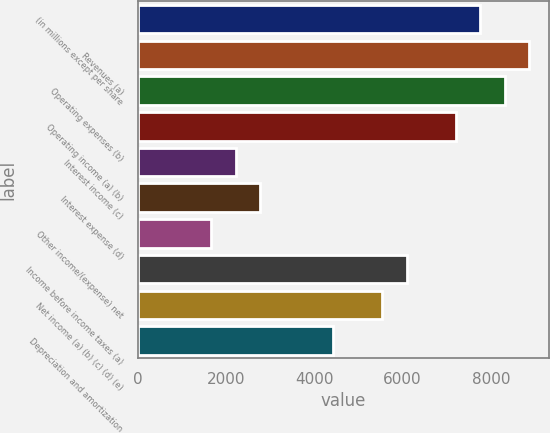<chart> <loc_0><loc_0><loc_500><loc_500><bar_chart><fcel>(in millions except per share<fcel>Revenues (a)<fcel>Operating expenses (b)<fcel>Operating income (a) (b)<fcel>Interest income (c)<fcel>Interest expense (d)<fcel>Other income/(expense) net<fcel>Income before income taxes (a)<fcel>Net income (a) (b) (c) (d) (e)<fcel>Depreciation and amortization<nl><fcel>7758.6<fcel>8866.9<fcel>8312.75<fcel>7204.45<fcel>2217.1<fcel>2771.25<fcel>1662.95<fcel>6096.15<fcel>5542<fcel>4433.7<nl></chart> 